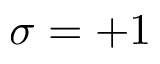<formula> <loc_0><loc_0><loc_500><loc_500>\sigma = + 1</formula> 